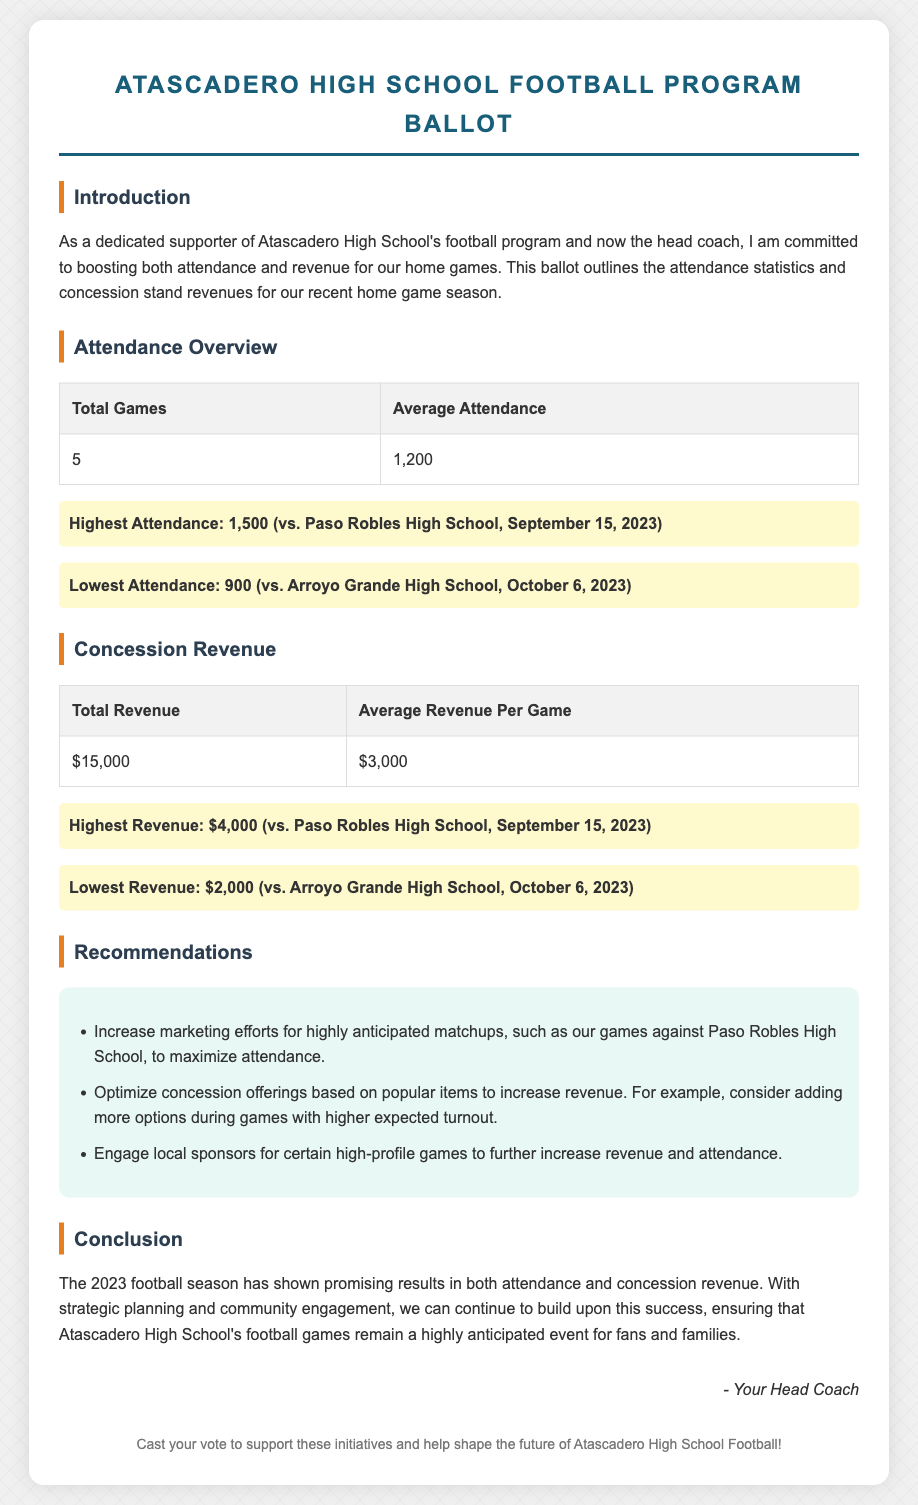what is the total number of games played? The total number of games is specified in the attendance overview table, which lists 5 games.
Answer: 5 what is the average attendance of the games? The average attendance is given in the attendance overview table as 1,200.
Answer: 1,200 what was the highest attendance recorded? The highest attendance for a game is highlighted in the attendance section, listed as 1,500.
Answer: 1,500 what was the total concession revenue? The total revenue from concessions is stated in the concession revenue table as $15,000.
Answer: $15,000 what is the average revenue per game from concessions? The average revenue per game is provided in the concession revenue table as $3,000.
Answer: $3,000 which game had the highest revenue? The game with the highest revenue is noted in the concession section, which was against Paso Robles High School on September 15, 2023.
Answer: vs. Paso Robles High School, September 15, 2023 what recommendation is given to optimize concession offerings? One of the recommendations suggests optimizing concession offerings based on popular items.
Answer: Optimize concession offerings how can attendance be maximized for future games? The document recommends increasing marketing efforts for highly anticipated matchups to boost attendance.
Answer: Increase marketing efforts what does the conclusion indicate about the 2023 football season? The conclusion reflects on promising results in both attendance and revenue, stating potential for continued success.
Answer: Promising results 